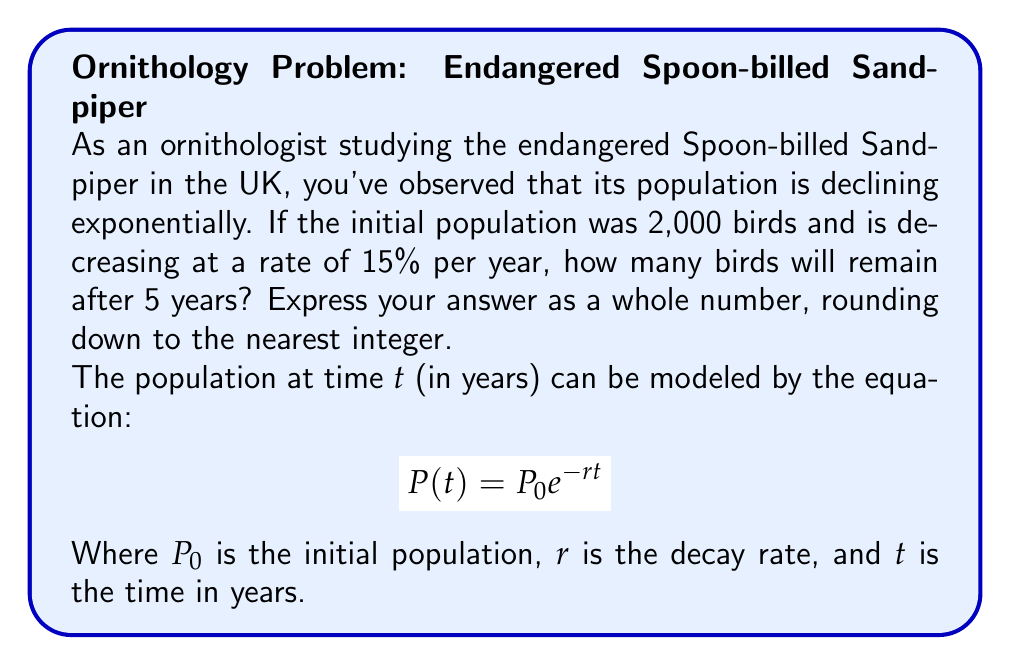Could you help me with this problem? Let's approach this step-by-step:

1) We are given:
   - Initial population, $P_0 = 2000$
   - Decay rate, $r = 15\% = 0.15$
   - Time, $t = 5$ years

2) We'll use the exponential decay formula:
   $$ P(t) = P_0 e^{-rt} $$

3) Substituting our values:
   $$ P(5) = 2000 e^{-0.15 \cdot 5} $$

4) Simplify the exponent:
   $$ P(5) = 2000 e^{-0.75} $$

5) Calculate $e^{-0.75}$ (using a calculator):
   $$ e^{-0.75} \approx 0.4724 $$

6) Multiply:
   $$ P(5) = 2000 \cdot 0.4724 \approx 944.8 $$

7) Rounding down to the nearest integer:
   $$ P(5) \approx 944 $$

Therefore, after 5 years, there will be approximately 944 Spoon-billed Sandpipers remaining.
Answer: 944 